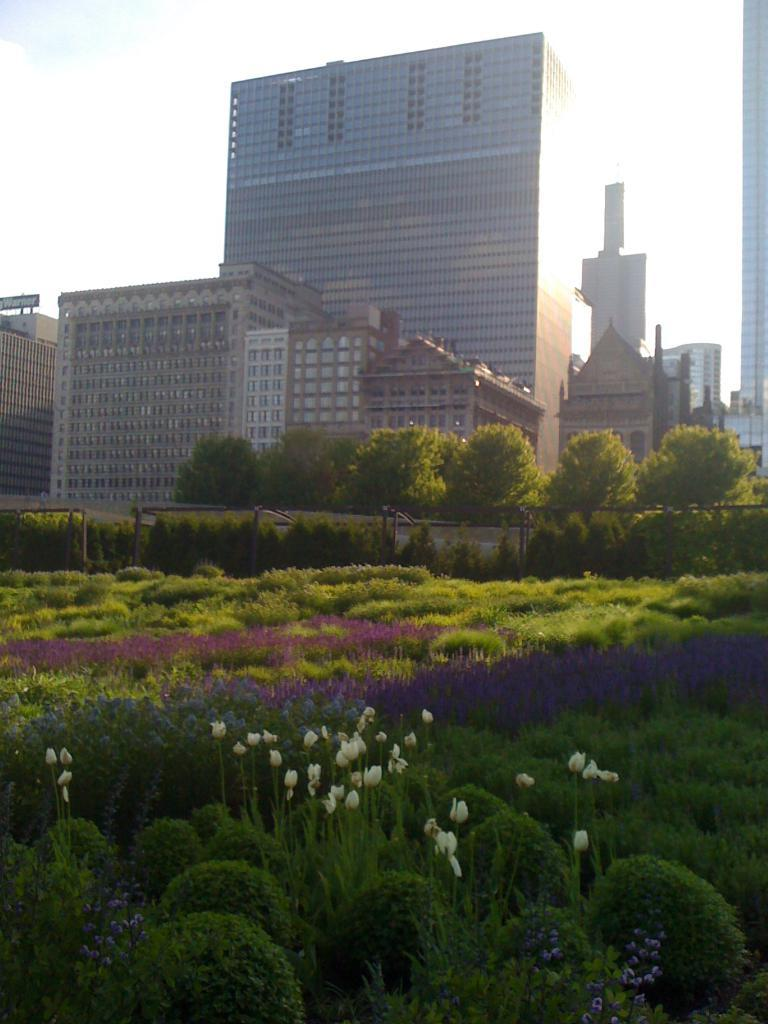What type of outdoor space is depicted in the image? There is a garden in the image. What can be seen in the background of the garden? There are trees and buildings in the background of the image. What is visible in the sky in the image? The sky is visible in the background of the image. What reason does the table have for being in the alley in the image? There is no table or alley present in the image; it features a garden with trees, buildings, and sky in the background. 